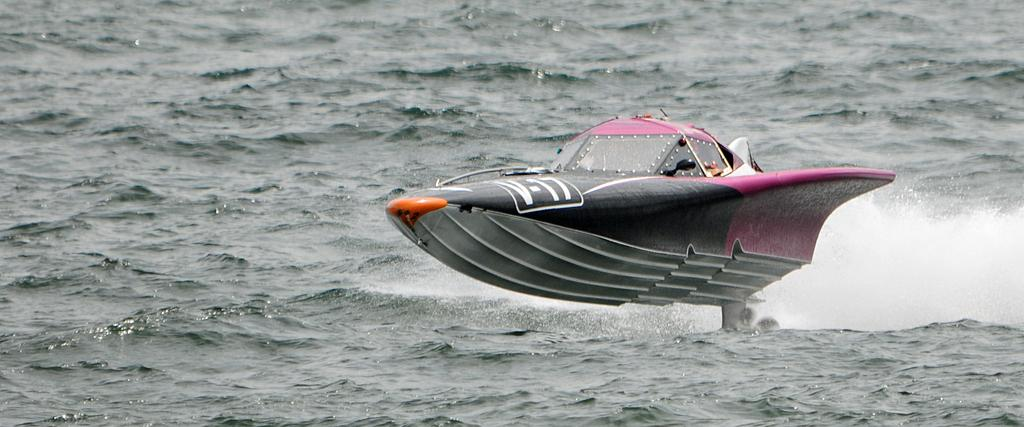What type of vehicle is in the image? There is a speedboat in the image. Where is the speedboat located? The speedboat is on the water. What type of mint can be seen growing near the speedboat in the image? A: There is no mint visible in the image; it only features a speedboat on the water. 